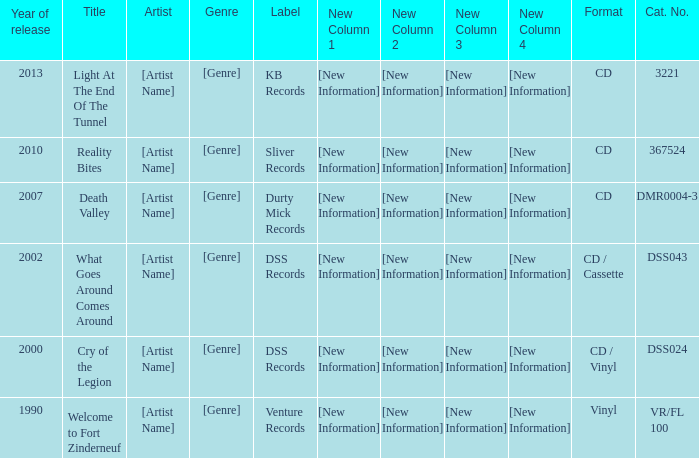What is the total year of release of the title what goes around comes around? 1.0. 